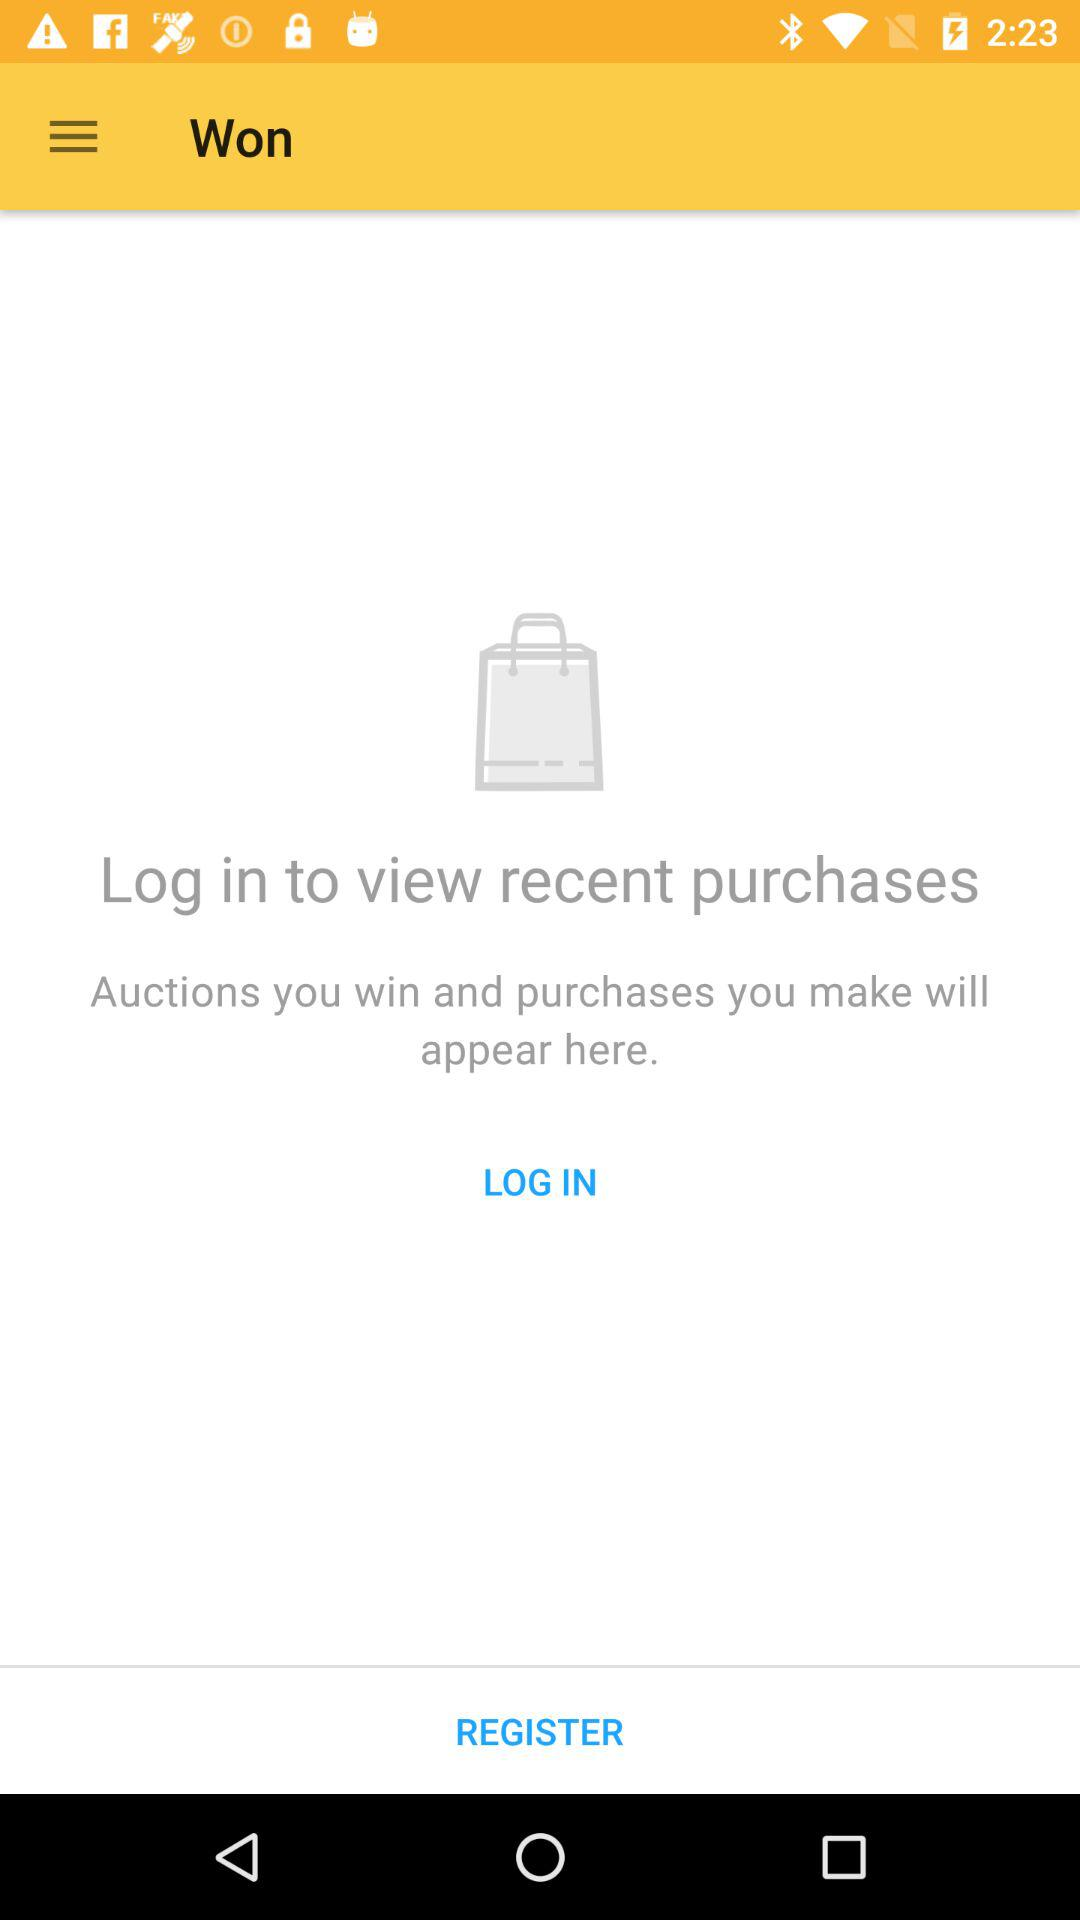How to view recent purchases? View recent purchases by logging in. 